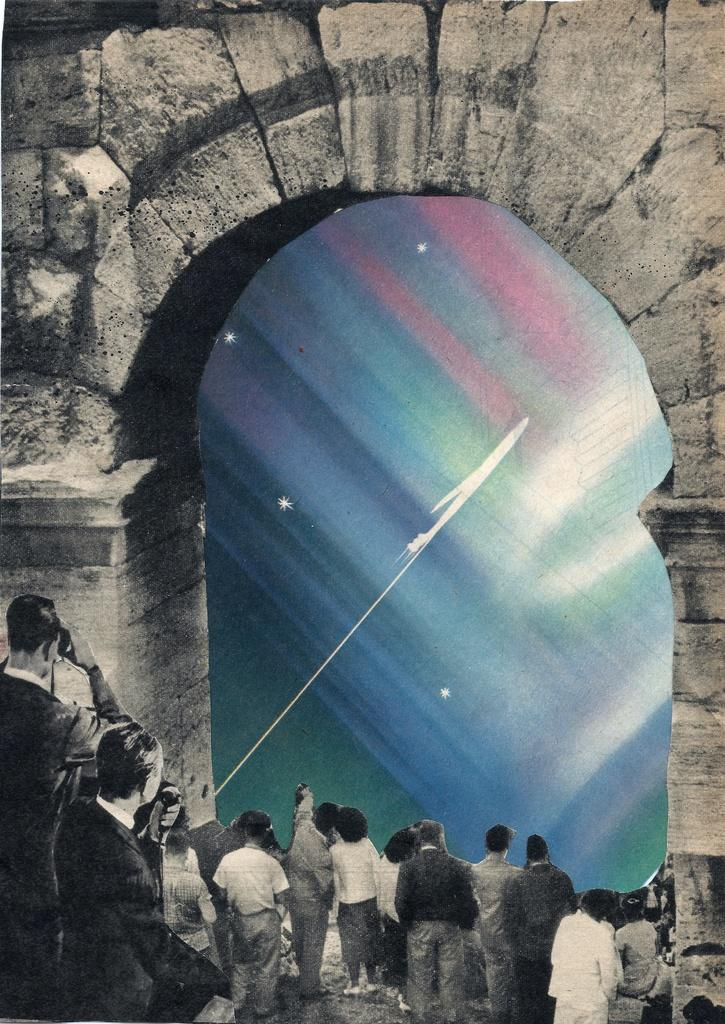How many people are in the image? There are persons in the image, but the exact number is not specified. What are the persons doing in the image? The persons are standing at an arch. What type of haircut is the person on the left side of the image getting? There is no information about haircuts or any person on the left side of the image, as the facts only mention that the persons are standing at an arch. 